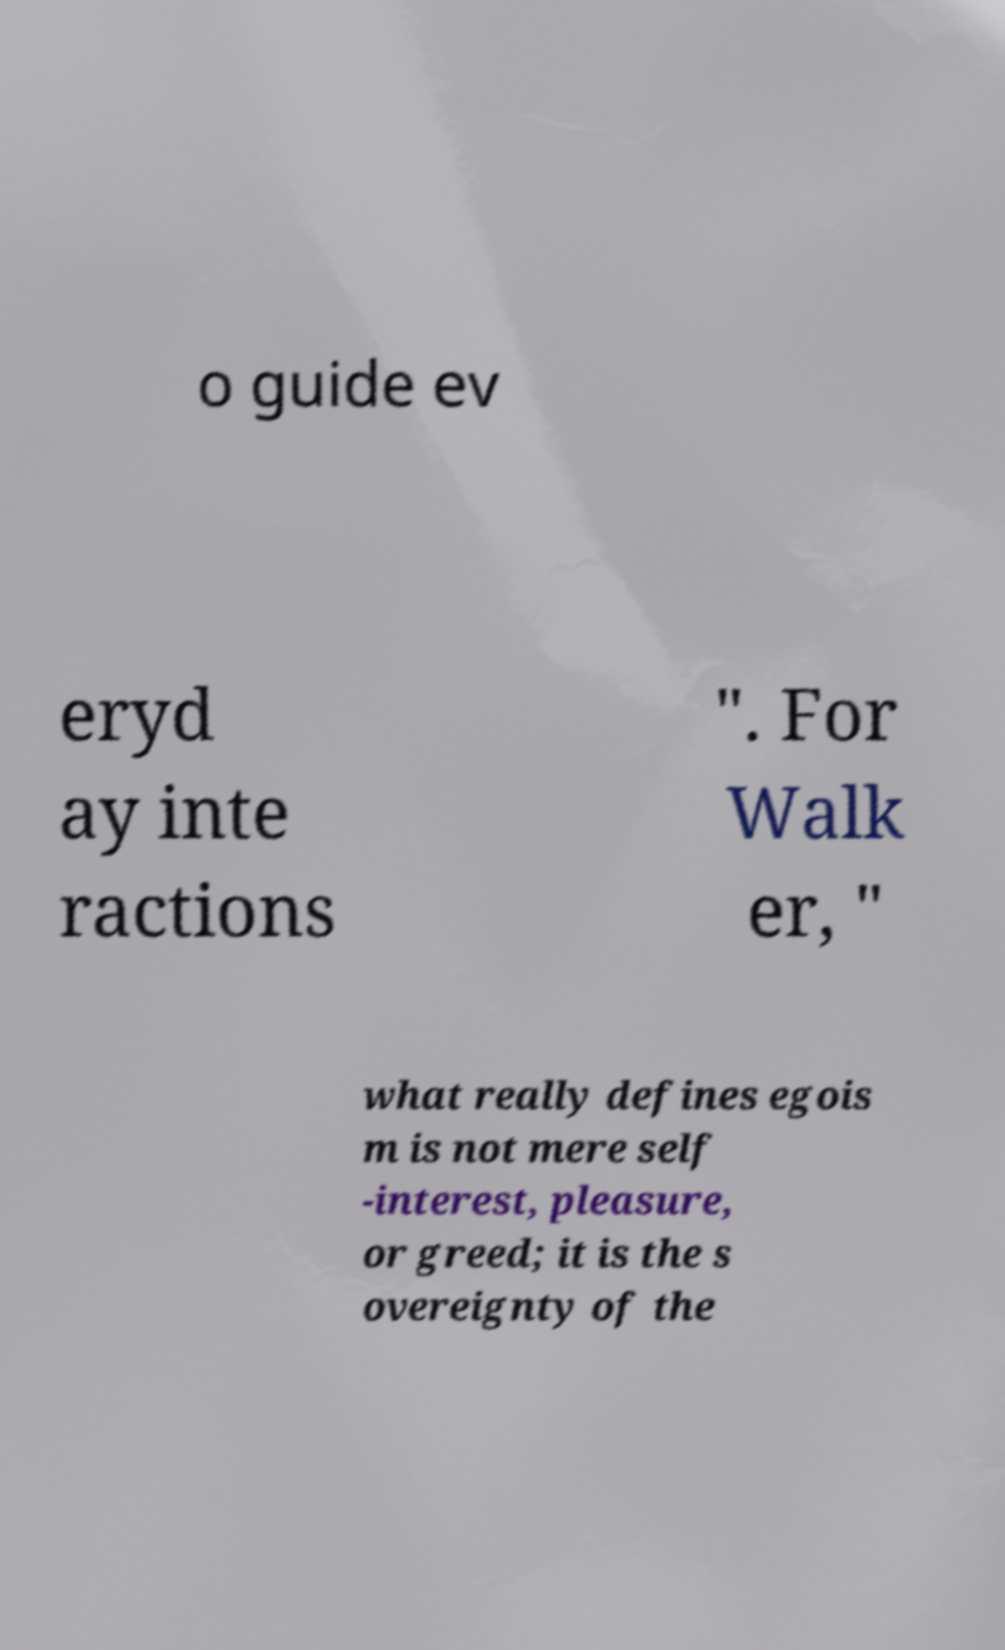Can you accurately transcribe the text from the provided image for me? o guide ev eryd ay inte ractions ". For Walk er, " what really defines egois m is not mere self -interest, pleasure, or greed; it is the s overeignty of the 